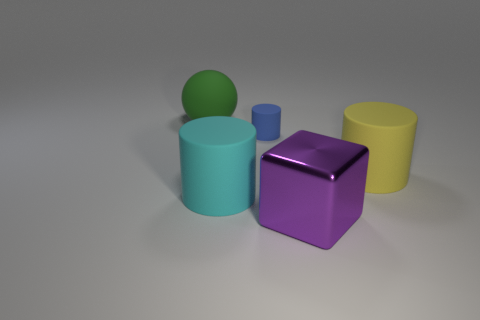How many big things are either brown cylinders or spheres?
Provide a short and direct response. 1. Do the big cylinder to the right of the blue rubber cylinder and the big green sphere have the same material?
Keep it short and to the point. Yes. There is a large rubber thing behind the yellow cylinder; what color is it?
Offer a terse response. Green. Is there a green object of the same size as the cyan matte cylinder?
Give a very brief answer. Yes. There is a purple block that is the same size as the green object; what material is it?
Your answer should be very brief. Metal. There is a yellow matte cylinder; is its size the same as the matte thing behind the tiny rubber cylinder?
Provide a succinct answer. Yes. There is a cylinder that is in front of the yellow cylinder; what material is it?
Make the answer very short. Rubber. Are there the same number of blue matte cylinders left of the large green rubber thing and small yellow metal blocks?
Provide a succinct answer. Yes. Do the green matte object and the cyan cylinder have the same size?
Provide a succinct answer. Yes. Are there any green spheres on the left side of the big rubber object in front of the big rubber cylinder that is on the right side of the cyan object?
Provide a succinct answer. Yes. 